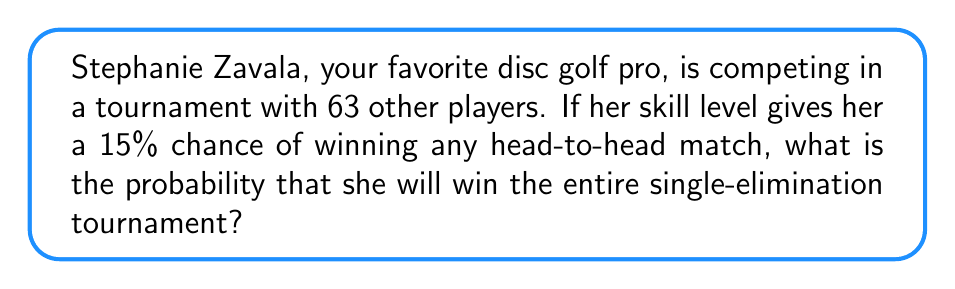What is the answer to this math problem? Let's approach this step-by-step:

1) In a single-elimination tournament with 64 players, a player needs to win 6 rounds to be the champion (64 → 32 → 16 → 8 → 4 → 2 → 1).

2) For Stephanie to win the tournament, she needs to win all 6 of her matches.

3) The probability of winning each match is 15% or 0.15.

4) To find the probability of winning all 6 matches, we multiply the probabilities:

   $$P(\text{winning tournament}) = 0.15 \times 0.15 \times 0.15 \times 0.15 \times 0.15 \times 0.15$$

5) This can be written as:

   $$P(\text{winning tournament}) = 0.15^6$$

6) Calculate:
   $$0.15^6 = 0.0000114974609375$$

7) Convert to percentage:
   $$0.0000114974609375 \times 100\% \approx 0.00115\%$$
Answer: $0.00115\%$ 